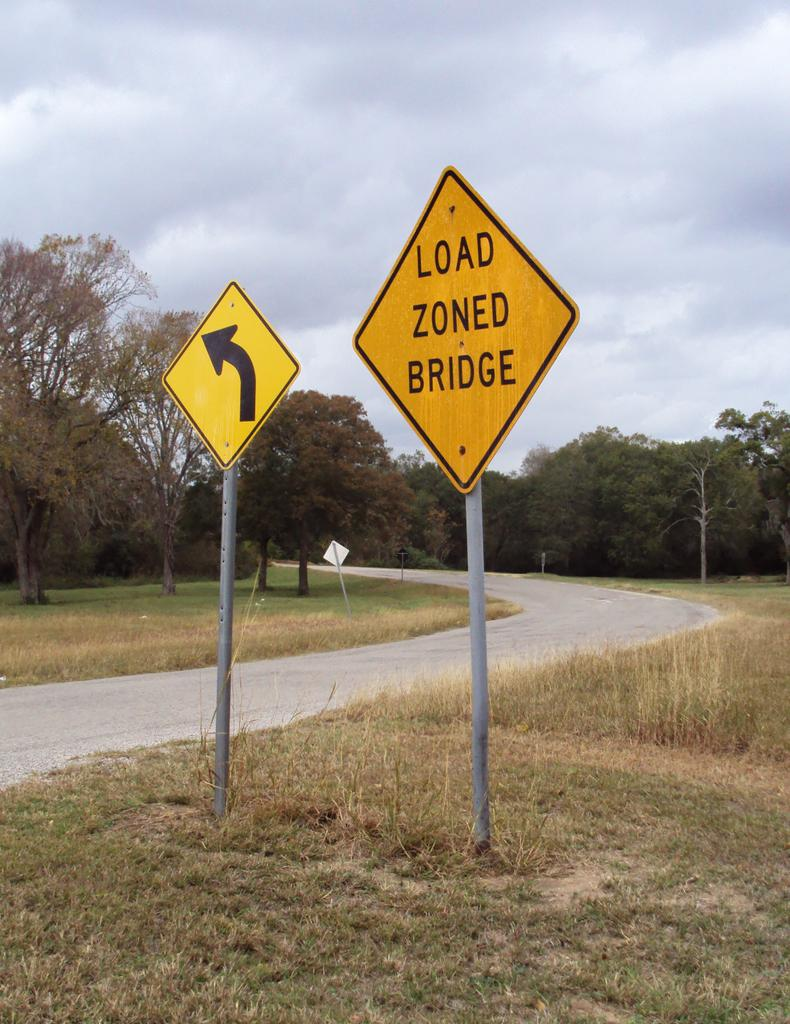<image>
Share a concise interpretation of the image provided. A sign that says Load Zoned Bridge is on the side of the road. 